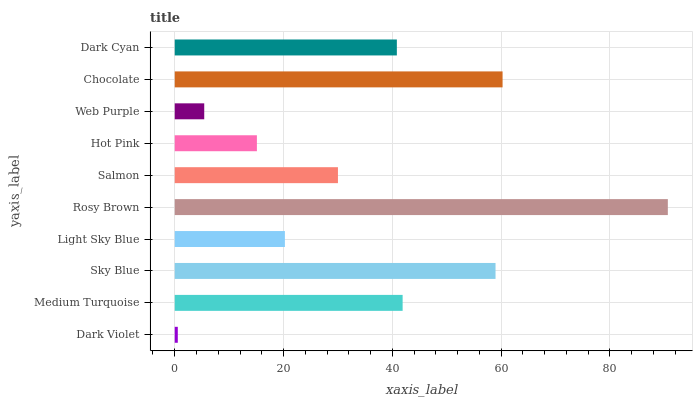Is Dark Violet the minimum?
Answer yes or no. Yes. Is Rosy Brown the maximum?
Answer yes or no. Yes. Is Medium Turquoise the minimum?
Answer yes or no. No. Is Medium Turquoise the maximum?
Answer yes or no. No. Is Medium Turquoise greater than Dark Violet?
Answer yes or no. Yes. Is Dark Violet less than Medium Turquoise?
Answer yes or no. Yes. Is Dark Violet greater than Medium Turquoise?
Answer yes or no. No. Is Medium Turquoise less than Dark Violet?
Answer yes or no. No. Is Dark Cyan the high median?
Answer yes or no. Yes. Is Salmon the low median?
Answer yes or no. Yes. Is Light Sky Blue the high median?
Answer yes or no. No. Is Sky Blue the low median?
Answer yes or no. No. 